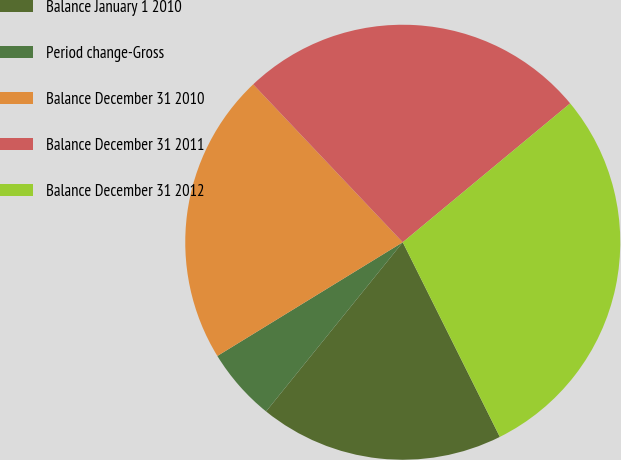Convert chart to OTSL. <chart><loc_0><loc_0><loc_500><loc_500><pie_chart><fcel>Balance January 1 2010<fcel>Period change-Gross<fcel>Balance December 31 2010<fcel>Balance December 31 2011<fcel>Balance December 31 2012<nl><fcel>18.18%<fcel>5.43%<fcel>21.69%<fcel>26.05%<fcel>28.66%<nl></chart> 